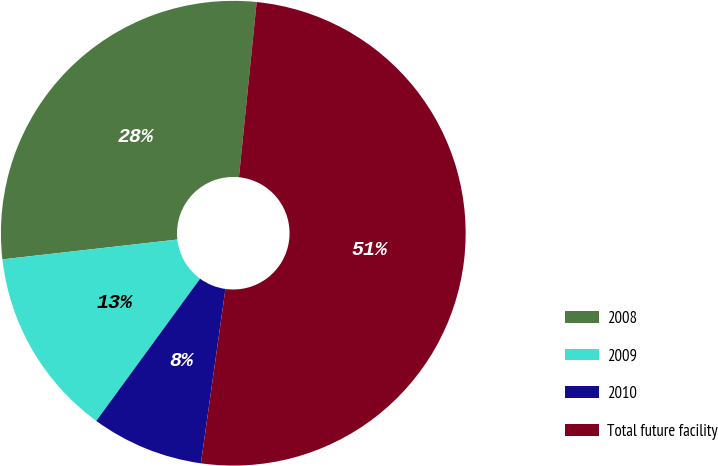Convert chart to OTSL. <chart><loc_0><loc_0><loc_500><loc_500><pie_chart><fcel>2008<fcel>2009<fcel>2010<fcel>Total future facility<nl><fcel>28.4%<fcel>13.17%<fcel>7.81%<fcel>50.62%<nl></chart> 